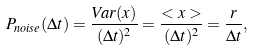Convert formula to latex. <formula><loc_0><loc_0><loc_500><loc_500>P _ { n o i s e } ( \Delta t ) = \frac { V a r ( x ) } { ( \Delta t ) ^ { 2 } } = \frac { < x > } { ( \Delta t ) ^ { 2 } } = \frac { r } { \Delta t } ,</formula> 